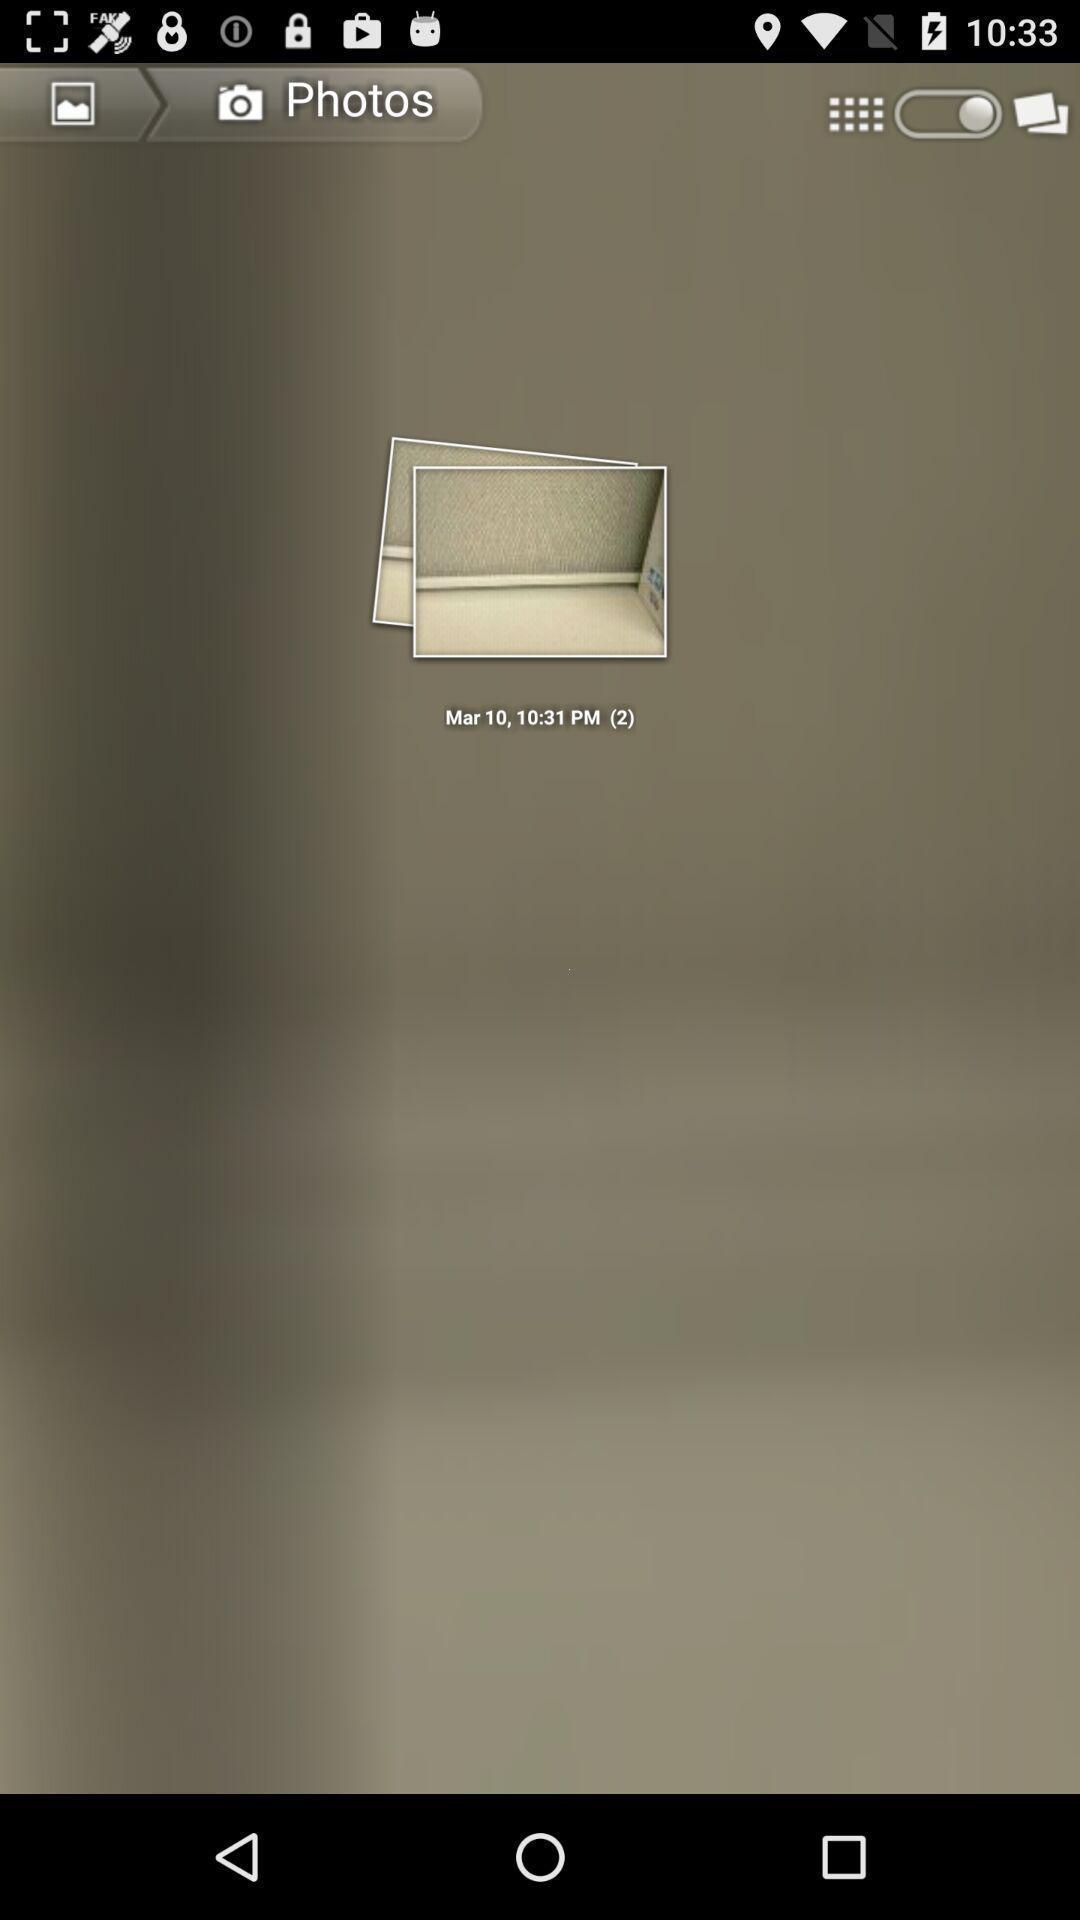Summarize the main components in this picture. Screen displaying image with options. 